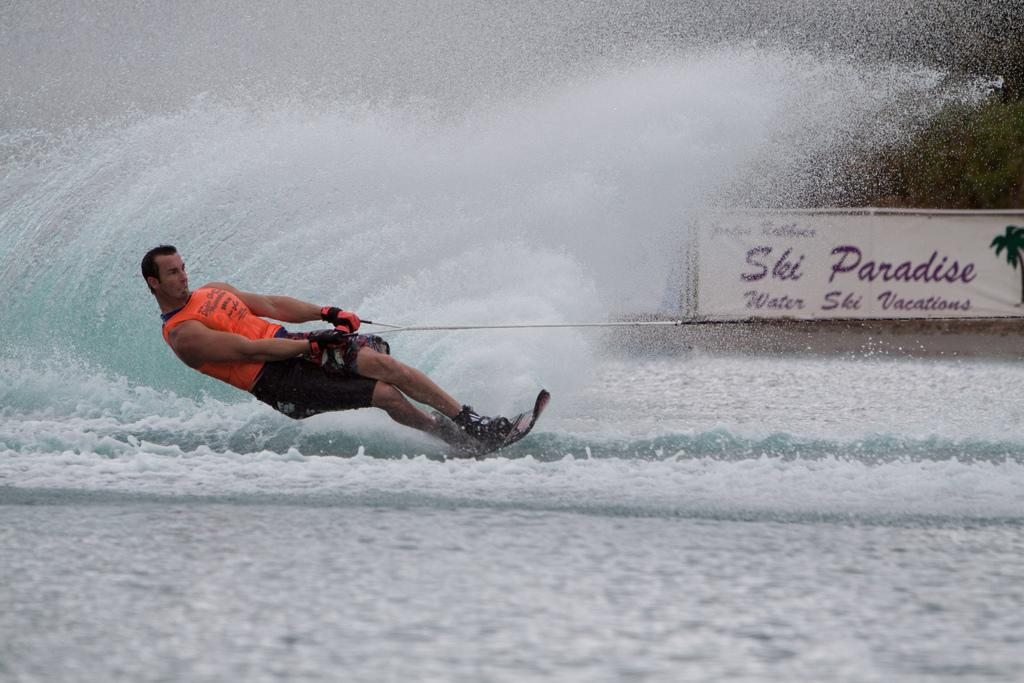What activity is the person in the image engaged in? The person is wakeboarding in the image. On what surface is the person wakeboarding? The person is wakeboarding on the water. Can you describe the equipment the person is using? There is a board on the right side of the image. What type of value can be seen on the board in the image? There is no value present on the board in the image. How many family members are visible in the image? There are no family members visible in the image; it only features a person wakeboarding. What type of rose is depicted on the board in the image? There is no rose depicted on the board in the image. 